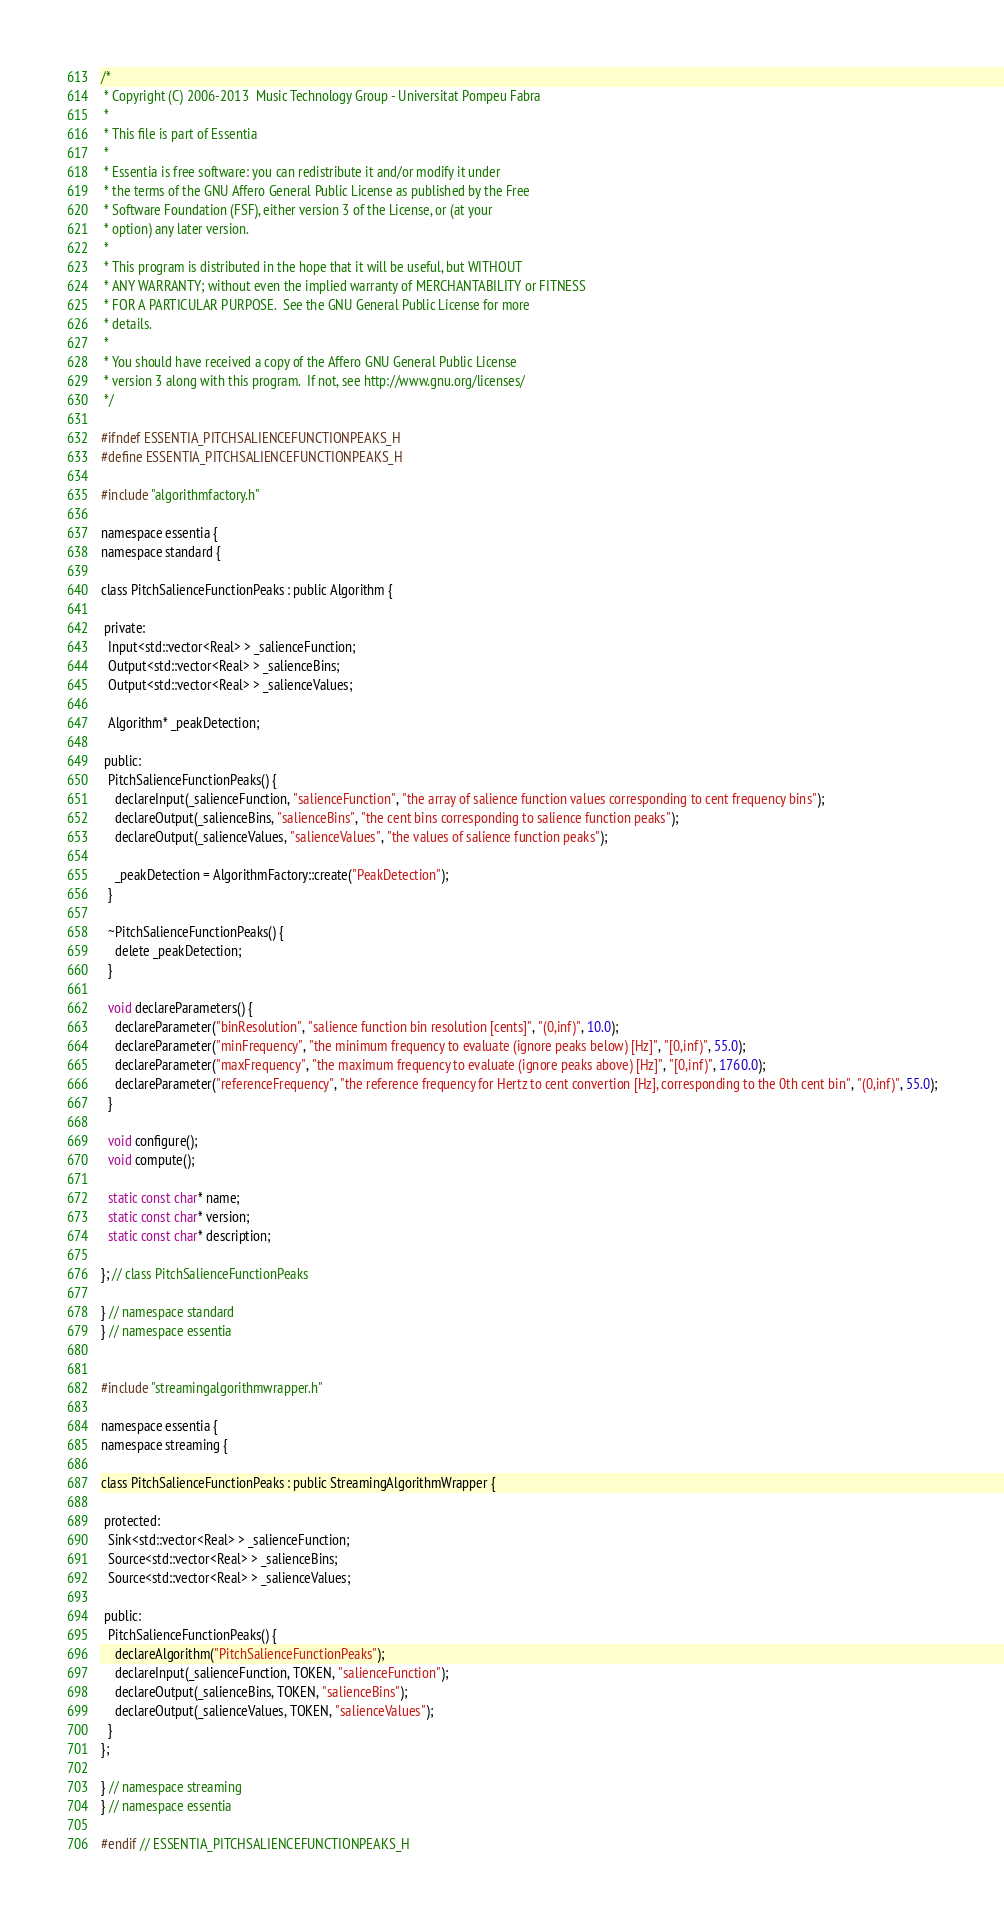Convert code to text. <code><loc_0><loc_0><loc_500><loc_500><_C_>/*
 * Copyright (C) 2006-2013  Music Technology Group - Universitat Pompeu Fabra
 *
 * This file is part of Essentia
 *
 * Essentia is free software: you can redistribute it and/or modify it under
 * the terms of the GNU Affero General Public License as published by the Free
 * Software Foundation (FSF), either version 3 of the License, or (at your
 * option) any later version.
 *
 * This program is distributed in the hope that it will be useful, but WITHOUT
 * ANY WARRANTY; without even the implied warranty of MERCHANTABILITY or FITNESS
 * FOR A PARTICULAR PURPOSE.  See the GNU General Public License for more
 * details.
 *
 * You should have received a copy of the Affero GNU General Public License
 * version 3 along with this program.  If not, see http://www.gnu.org/licenses/
 */

#ifndef ESSENTIA_PITCHSALIENCEFUNCTIONPEAKS_H
#define ESSENTIA_PITCHSALIENCEFUNCTIONPEAKS_H

#include "algorithmfactory.h"

namespace essentia {
namespace standard {

class PitchSalienceFunctionPeaks : public Algorithm {

 private:
  Input<std::vector<Real> > _salienceFunction;
  Output<std::vector<Real> > _salienceBins;
  Output<std::vector<Real> > _salienceValues;

  Algorithm* _peakDetection;

 public:
  PitchSalienceFunctionPeaks() {
    declareInput(_salienceFunction, "salienceFunction", "the array of salience function values corresponding to cent frequency bins");
    declareOutput(_salienceBins, "salienceBins", "the cent bins corresponding to salience function peaks");
    declareOutput(_salienceValues, "salienceValues", "the values of salience function peaks");

    _peakDetection = AlgorithmFactory::create("PeakDetection");
  }

  ~PitchSalienceFunctionPeaks() {
    delete _peakDetection;
  }

  void declareParameters() {
    declareParameter("binResolution", "salience function bin resolution [cents]", "(0,inf)", 10.0);
    declareParameter("minFrequency", "the minimum frequency to evaluate (ignore peaks below) [Hz]", "[0,inf)", 55.0);
    declareParameter("maxFrequency", "the maximum frequency to evaluate (ignore peaks above) [Hz]", "[0,inf)", 1760.0);
    declareParameter("referenceFrequency", "the reference frequency for Hertz to cent convertion [Hz], corresponding to the 0th cent bin", "(0,inf)", 55.0);
  }

  void configure();
  void compute();

  static const char* name;
  static const char* version;
  static const char* description;

}; // class PitchSalienceFunctionPeaks

} // namespace standard
} // namespace essentia


#include "streamingalgorithmwrapper.h"

namespace essentia {
namespace streaming {

class PitchSalienceFunctionPeaks : public StreamingAlgorithmWrapper {

 protected:
  Sink<std::vector<Real> > _salienceFunction;
  Source<std::vector<Real> > _salienceBins;
  Source<std::vector<Real> > _salienceValues;

 public:
  PitchSalienceFunctionPeaks() {
    declareAlgorithm("PitchSalienceFunctionPeaks");
    declareInput(_salienceFunction, TOKEN, "salienceFunction");
    declareOutput(_salienceBins, TOKEN, "salienceBins");
    declareOutput(_salienceValues, TOKEN, "salienceValues");
  }
};

} // namespace streaming
} // namespace essentia

#endif // ESSENTIA_PITCHSALIENCEFUNCTIONPEAKS_H
</code> 